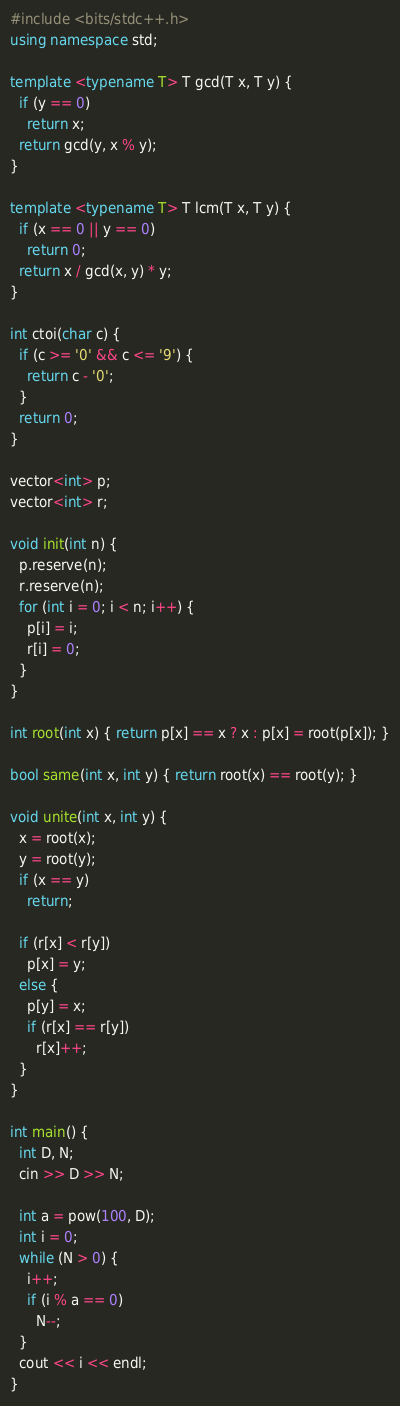Convert code to text. <code><loc_0><loc_0><loc_500><loc_500><_C++_>#include <bits/stdc++.h>
using namespace std;

template <typename T> T gcd(T x, T y) {
  if (y == 0)
    return x;
  return gcd(y, x % y);
}

template <typename T> T lcm(T x, T y) {
  if (x == 0 || y == 0)
    return 0;
  return x / gcd(x, y) * y;
}

int ctoi(char c) {
  if (c >= '0' && c <= '9') {
    return c - '0';
  }
  return 0;
}

vector<int> p;
vector<int> r;

void init(int n) {
  p.reserve(n);
  r.reserve(n);
  for (int i = 0; i < n; i++) {
    p[i] = i;
    r[i] = 0;
  }
}

int root(int x) { return p[x] == x ? x : p[x] = root(p[x]); }

bool same(int x, int y) { return root(x) == root(y); }

void unite(int x, int y) {
  x = root(x);
  y = root(y);
  if (x == y)
    return;

  if (r[x] < r[y])
    p[x] = y;
  else {
    p[y] = x;
    if (r[x] == r[y])
      r[x]++;
  }
}

int main() {
  int D, N;
  cin >> D >> N;

  int a = pow(100, D);
  int i = 0;
  while (N > 0) {
    i++;
    if (i % a == 0)
      N--;
  }
  cout << i << endl;
}
</code> 